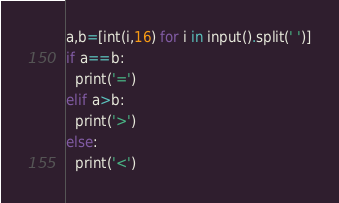<code> <loc_0><loc_0><loc_500><loc_500><_Python_>a,b=[int(i,16) for i in input().split(' ')]
if a==b:
  print('=')
elif a>b:
  print('>')
else:
  print('<')</code> 